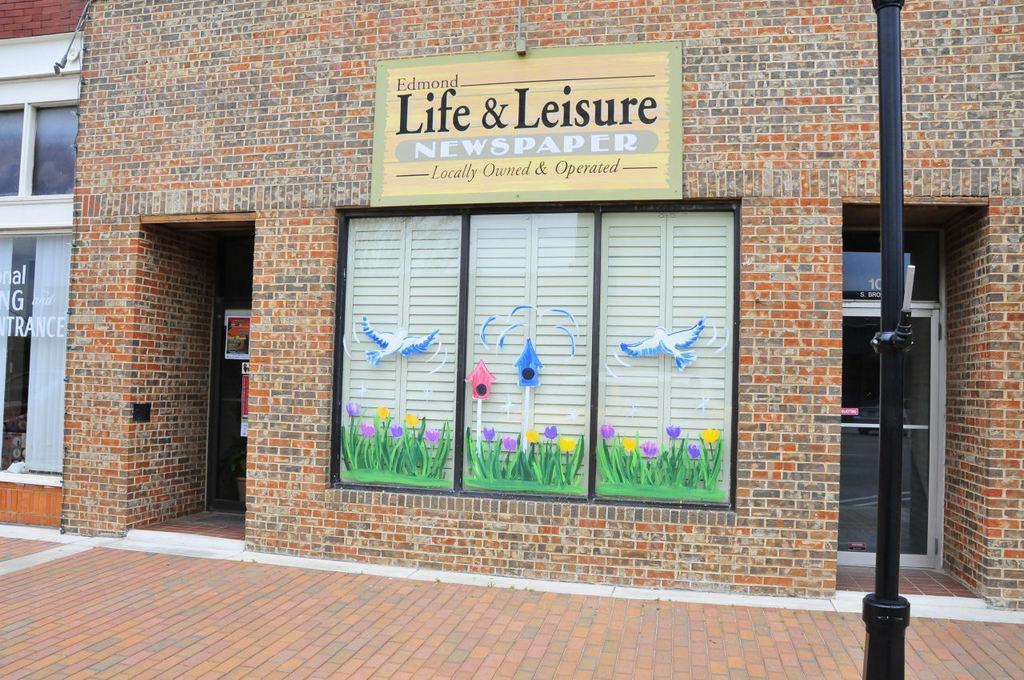Describe this image in one or two sentences. In this image we can see a building with brick wall, doors. On the building there is a board with something written. Also there are glass windows with paintings. And there is a pole on the right side. 